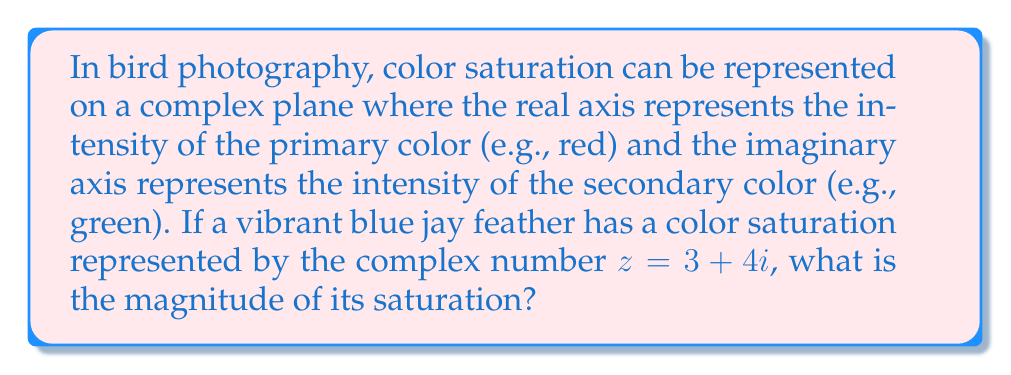Solve this math problem. To determine the magnitude of color saturation represented by a complex number, we need to calculate its absolute value or modulus. For a complex number $z = a + bi$, the magnitude is given by the formula:

$$|z| = \sqrt{a^2 + b^2}$$

In this case, we have $z = 3 + 4i$, so $a = 3$ and $b = 4$.

Let's substitute these values into the formula:

$$|z| = \sqrt{3^2 + 4^2}$$

$$|z| = \sqrt{9 + 16}$$

$$|z| = \sqrt{25}$$

$$|z| = 5$$

This result, 5, represents the magnitude of the color saturation for the blue jay feather in the complex plane representation.
Answer: $5$ 